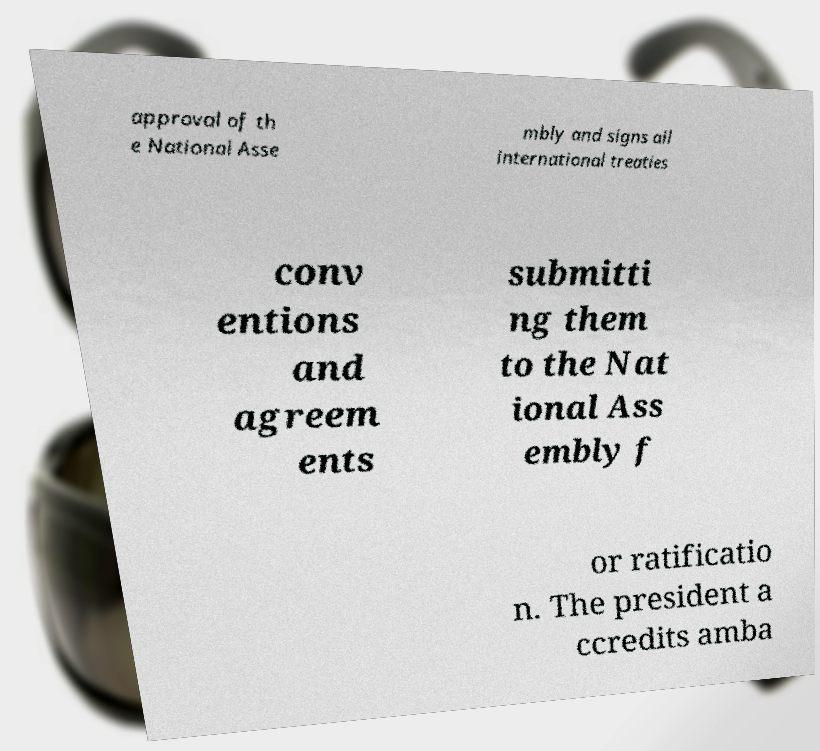Please identify and transcribe the text found in this image. approval of th e National Asse mbly and signs all international treaties conv entions and agreem ents submitti ng them to the Nat ional Ass embly f or ratificatio n. The president a ccredits amba 